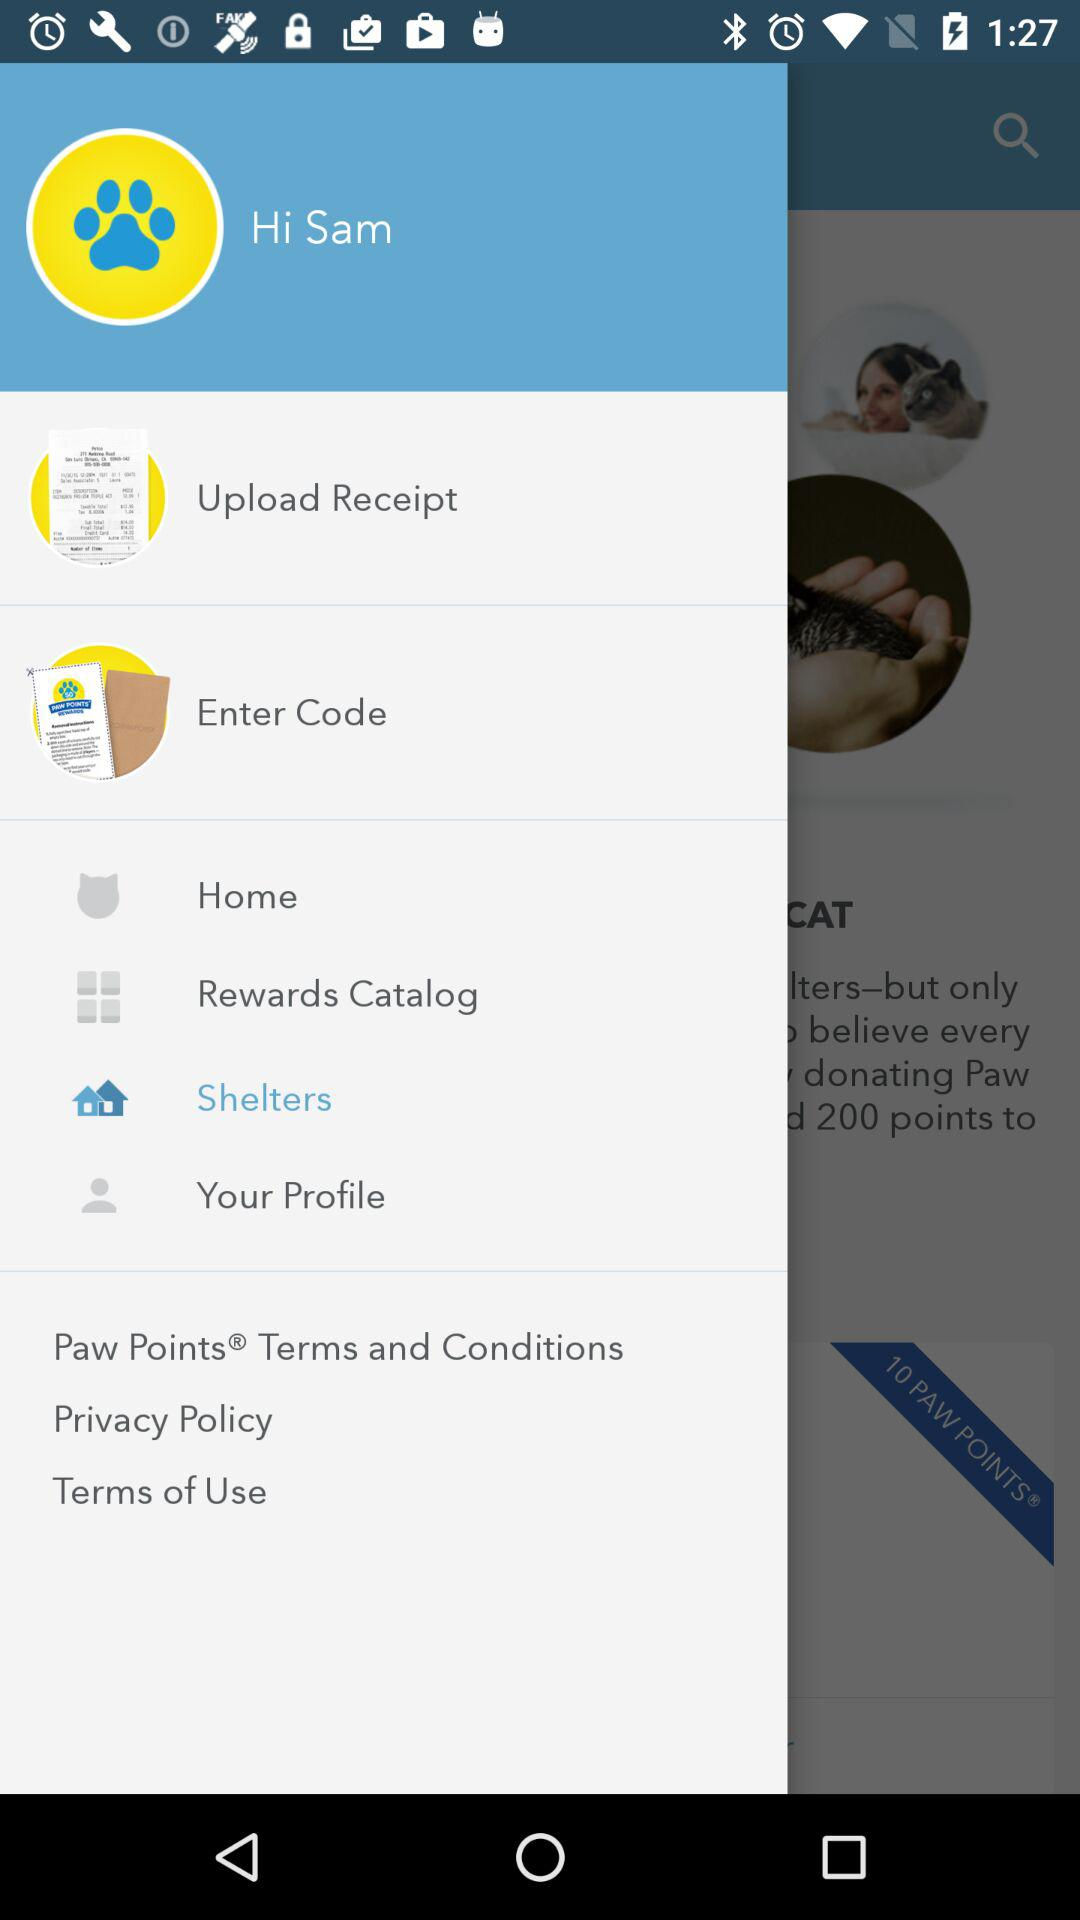What is the user name? The user name is Sam. 